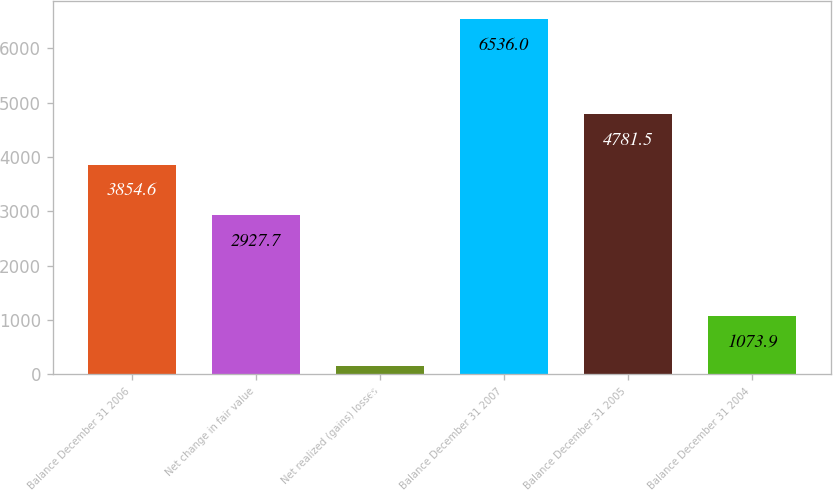Convert chart to OTSL. <chart><loc_0><loc_0><loc_500><loc_500><bar_chart><fcel>Balance December 31 2006<fcel>Net change in fair value<fcel>Net realized (gains) losses<fcel>Balance December 31 2007<fcel>Balance December 31 2005<fcel>Balance December 31 2004<nl><fcel>3854.6<fcel>2927.7<fcel>147<fcel>6536<fcel>4781.5<fcel>1073.9<nl></chart> 